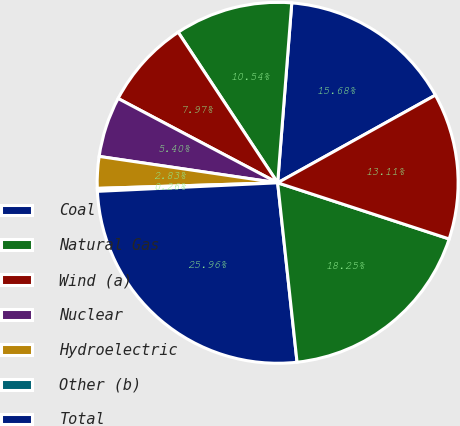<chart> <loc_0><loc_0><loc_500><loc_500><pie_chart><fcel>Coal<fcel>Natural Gas<fcel>Wind (a)<fcel>Nuclear<fcel>Hydroelectric<fcel>Other (b)<fcel>Total<fcel>Owned generation<fcel>Purchased generation<nl><fcel>15.68%<fcel>10.54%<fcel>7.97%<fcel>5.4%<fcel>2.83%<fcel>0.26%<fcel>25.96%<fcel>18.25%<fcel>13.11%<nl></chart> 